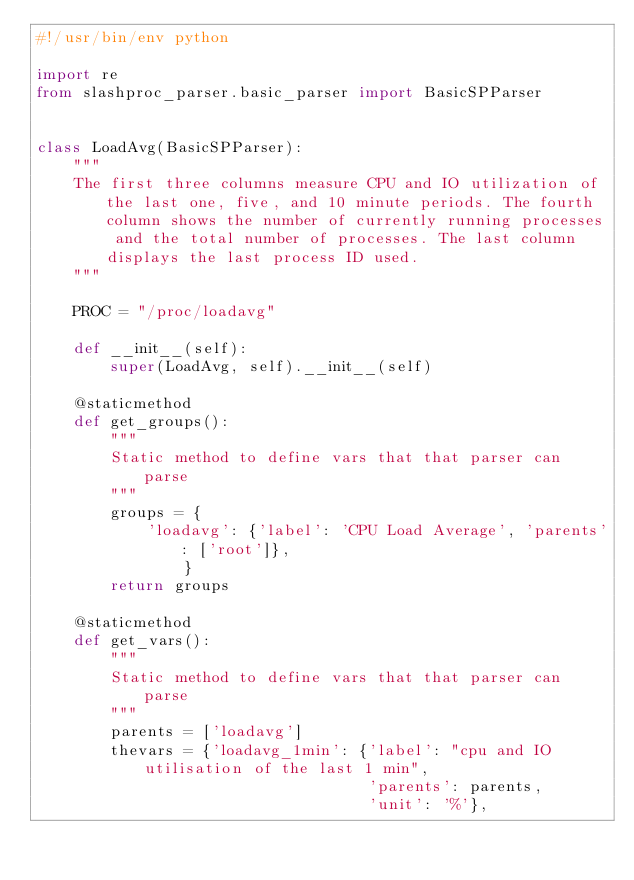Convert code to text. <code><loc_0><loc_0><loc_500><loc_500><_Python_>#!/usr/bin/env python

import re
from slashproc_parser.basic_parser import BasicSPParser


class LoadAvg(BasicSPParser):
    """
    The first three columns measure CPU and IO utilization of the last one, five, and 10 minute periods. The fourth column shows the number of currently running processes and the total number of processes. The last column displays the last process ID used.
    """

    PROC = "/proc/loadavg"

    def __init__(self):
        super(LoadAvg, self).__init__(self)

    @staticmethod
    def get_groups():
        """
        Static method to define vars that that parser can parse
        """
        groups = {
            'loadavg': {'label': 'CPU Load Average', 'parents': ['root']}, 
                }
        return groups
        
    @staticmethod
    def get_vars():
        """
        Static method to define vars that that parser can parse
        """
        parents = ['loadavg']
        thevars = {'loadavg_1min': {'label': "cpu and IO utilisation of the last 1 min",
                                    'parents': parents,
                                    'unit': '%'},</code> 